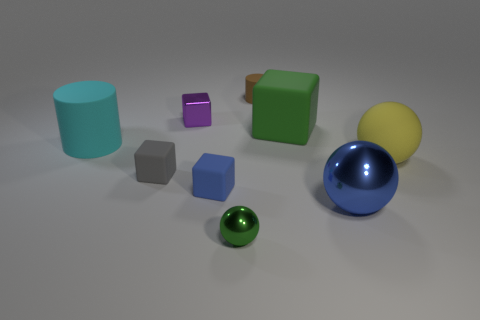What can you infer about the texture and materials of the objects? Based on the image, we can infer that the objects have a variety of textures and are likely made from different materials. The teal cylinder and the green cube appear to have a rubber-like texture which is matte and non-reflective. The purple and blue cubes are smoother with a slight sheen, suggesting a plastic material. The gray block is matte, possibly made of stone or concrete. The blue sphere is highly reflective and metallic, while the yellow sphere has a soft sheen indicating a possible plastic or painted wooden material. The small green sphere has a metallic luster, likely made of a material similar to the blue sphere. 